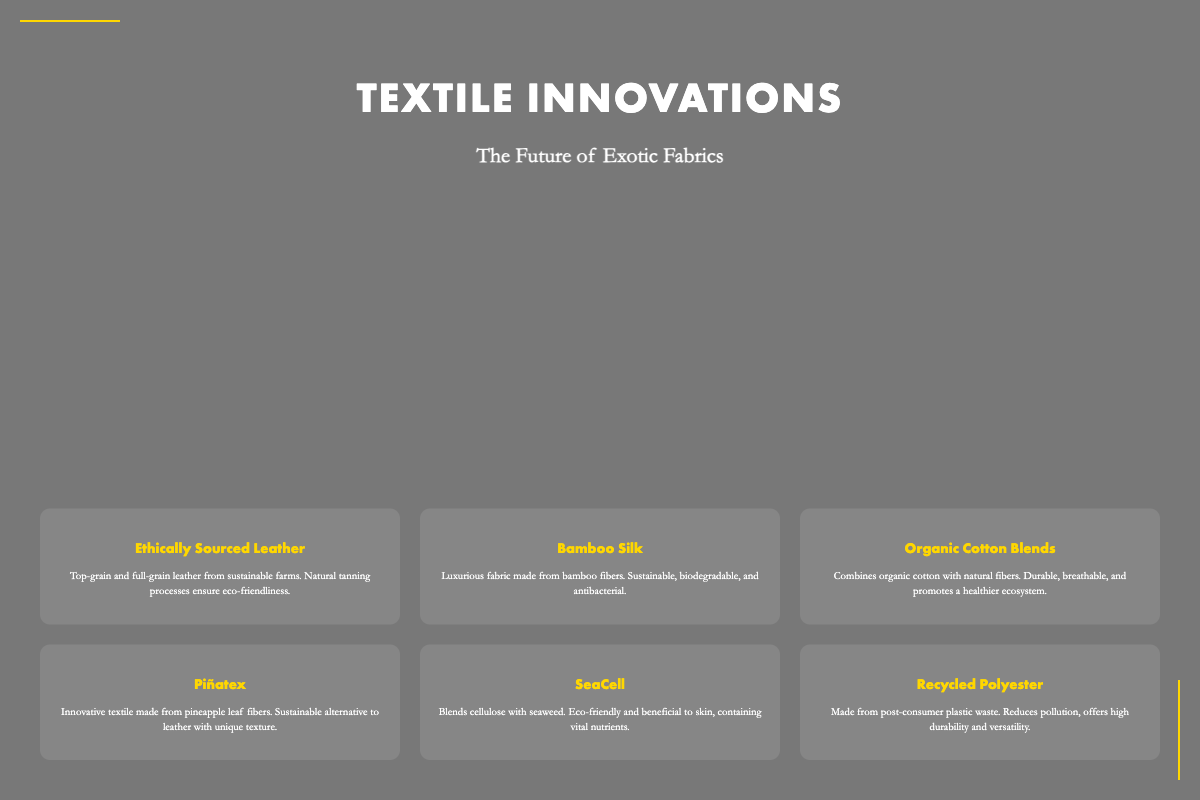What is the title of the book? The title is presented prominently at the top of the cover.
Answer: Textile Innovations What is the subtitle of the book? The subtitle is located underneath the title, providing further context.
Answer: The Future of Exotic Fabrics How many fabric items are displayed on the cover? There are six unique fabric items highlighted in the grid section of the cover.
Answer: Six What type of leather is mentioned? The fabric item specifies the kind of leather in its description.
Answer: Ethically Sourced Leather What sustainable fabric is made from pineapple leaf fibers? The description of this unique textile is found among the fabric items.
Answer: Piñatex What is the main benefit of Bamboo Silk? The innovative fabric description highlights its environmentally friendly characteristics.
Answer: Sustainable Which fabric description mentions post-consumer waste? The specific sustainable practice covering this fabric is indicated in its description.
Answer: Recycled Polyester What color scheme is predominantly used in the book cover? The background image and text are layered together, creating a specific visual tone.
Answer: Black and gold Which font is used for the title? This detail about the typography is specified in the document's styling.
Answer: Futura 